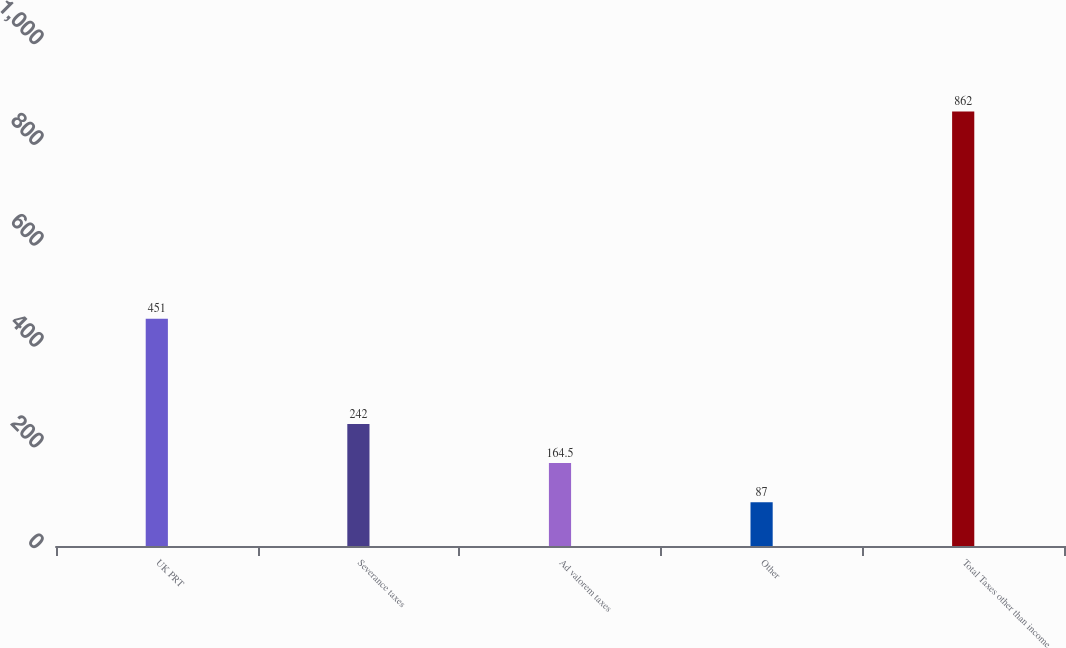<chart> <loc_0><loc_0><loc_500><loc_500><bar_chart><fcel>UK PRT<fcel>Severance taxes<fcel>Ad valorem taxes<fcel>Other<fcel>Total Taxes other than income<nl><fcel>451<fcel>242<fcel>164.5<fcel>87<fcel>862<nl></chart> 